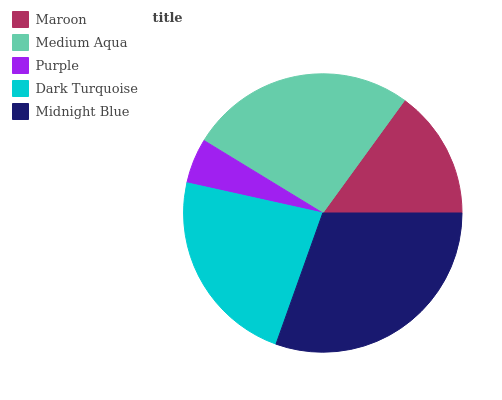Is Purple the minimum?
Answer yes or no. Yes. Is Midnight Blue the maximum?
Answer yes or no. Yes. Is Medium Aqua the minimum?
Answer yes or no. No. Is Medium Aqua the maximum?
Answer yes or no. No. Is Medium Aqua greater than Maroon?
Answer yes or no. Yes. Is Maroon less than Medium Aqua?
Answer yes or no. Yes. Is Maroon greater than Medium Aqua?
Answer yes or no. No. Is Medium Aqua less than Maroon?
Answer yes or no. No. Is Dark Turquoise the high median?
Answer yes or no. Yes. Is Dark Turquoise the low median?
Answer yes or no. Yes. Is Purple the high median?
Answer yes or no. No. Is Maroon the low median?
Answer yes or no. No. 